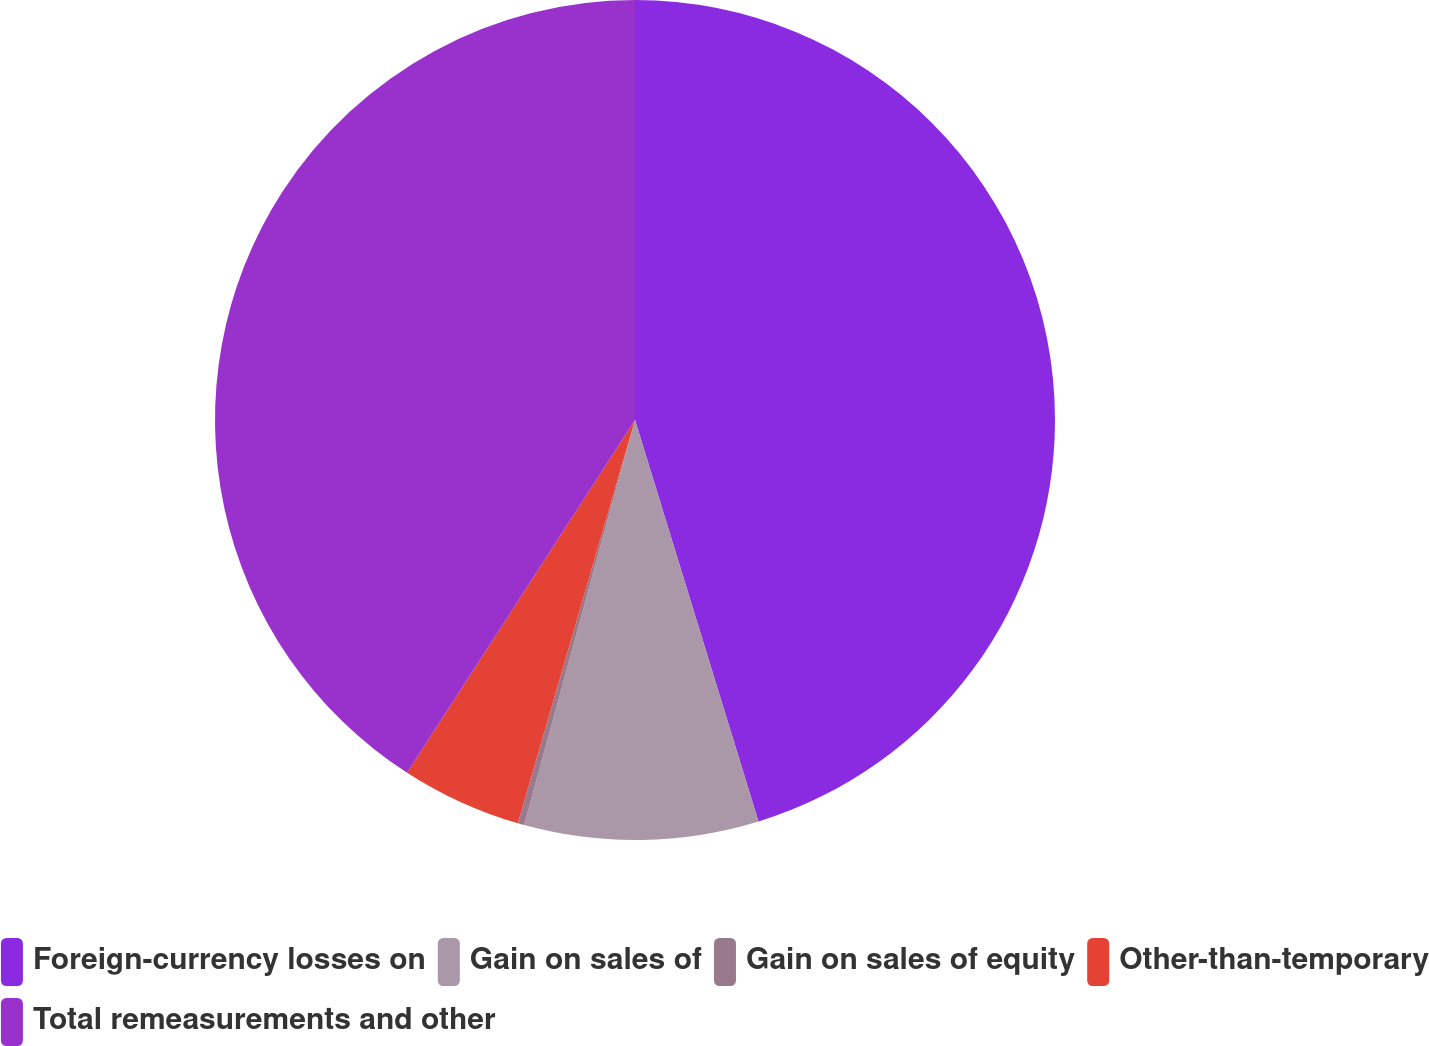Convert chart to OTSL. <chart><loc_0><loc_0><loc_500><loc_500><pie_chart><fcel>Foreign-currency losses on<fcel>Gain on sales of<fcel>Gain on sales of equity<fcel>Other-than-temporary<fcel>Total remeasurements and other<nl><fcel>45.25%<fcel>9.0%<fcel>0.25%<fcel>4.63%<fcel>40.87%<nl></chart> 